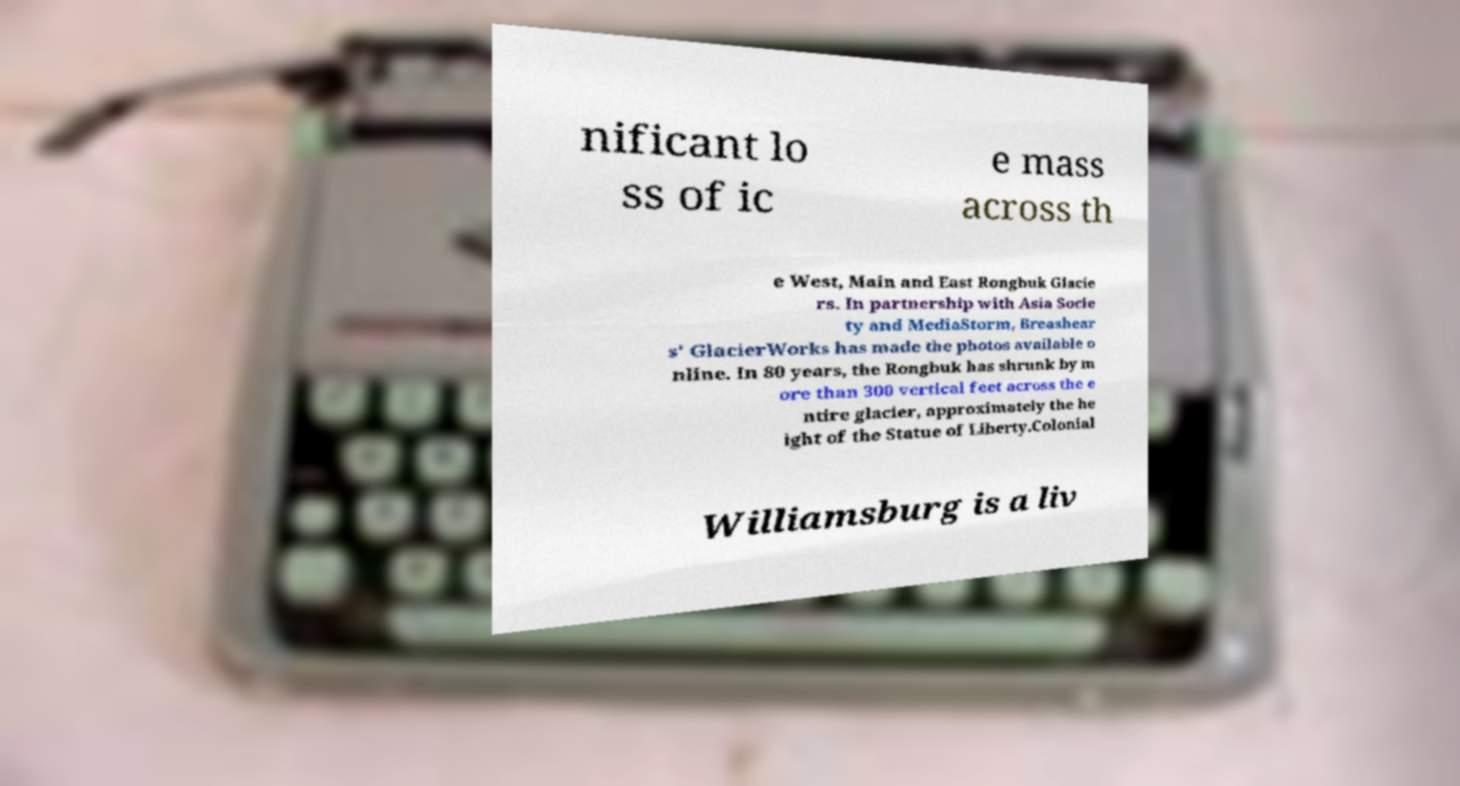Can you read and provide the text displayed in the image?This photo seems to have some interesting text. Can you extract and type it out for me? nificant lo ss of ic e mass across th e West, Main and East Rongbuk Glacie rs. In partnership with Asia Socie ty and MediaStorm, Breashear s' GlacierWorks has made the photos available o nline. In 80 years, the Rongbuk has shrunk by m ore than 300 vertical feet across the e ntire glacier, approximately the he ight of the Statue of Liberty.Colonial  Williamsburg is a liv 